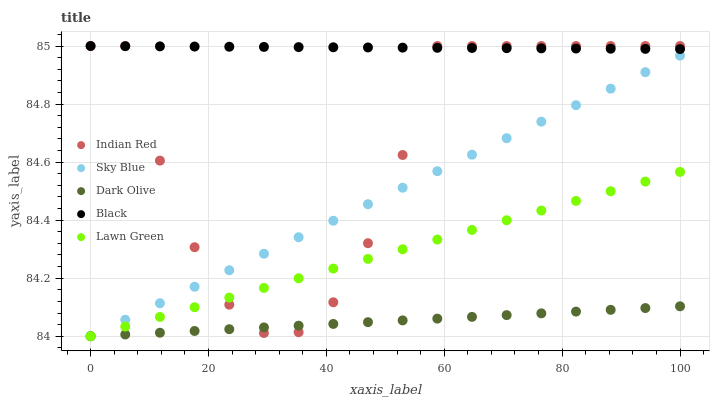Does Dark Olive have the minimum area under the curve?
Answer yes or no. Yes. Does Black have the maximum area under the curve?
Answer yes or no. Yes. Does Black have the minimum area under the curve?
Answer yes or no. No. Does Dark Olive have the maximum area under the curve?
Answer yes or no. No. Is Sky Blue the smoothest?
Answer yes or no. Yes. Is Indian Red the roughest?
Answer yes or no. Yes. Is Dark Olive the smoothest?
Answer yes or no. No. Is Dark Olive the roughest?
Answer yes or no. No. Does Sky Blue have the lowest value?
Answer yes or no. Yes. Does Black have the lowest value?
Answer yes or no. No. Does Indian Red have the highest value?
Answer yes or no. Yes. Does Dark Olive have the highest value?
Answer yes or no. No. Is Dark Olive less than Black?
Answer yes or no. Yes. Is Black greater than Sky Blue?
Answer yes or no. Yes. Does Sky Blue intersect Lawn Green?
Answer yes or no. Yes. Is Sky Blue less than Lawn Green?
Answer yes or no. No. Is Sky Blue greater than Lawn Green?
Answer yes or no. No. Does Dark Olive intersect Black?
Answer yes or no. No. 